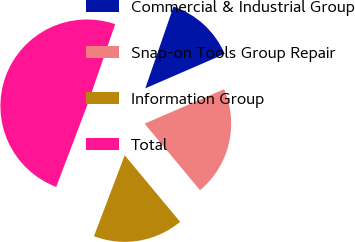<chart> <loc_0><loc_0><loc_500><loc_500><pie_chart><fcel>Commercial & Industrial Group<fcel>Snap-on Tools Group Repair<fcel>Information Group<fcel>Total<nl><fcel>13.2%<fcel>20.46%<fcel>16.83%<fcel>49.5%<nl></chart> 